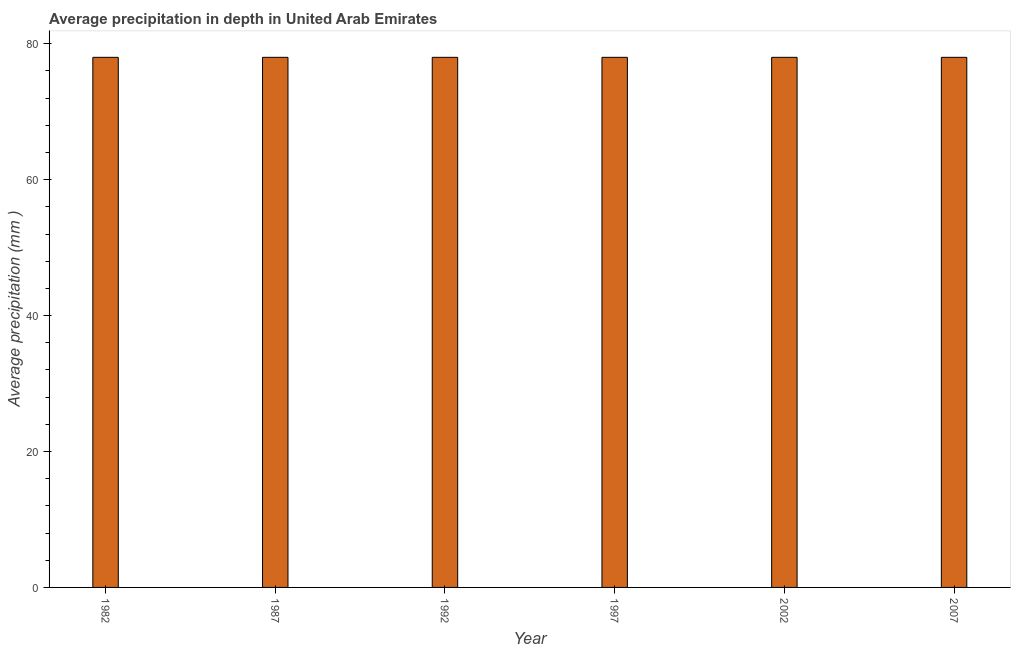Does the graph contain grids?
Provide a short and direct response. No. What is the title of the graph?
Keep it short and to the point. Average precipitation in depth in United Arab Emirates. What is the label or title of the X-axis?
Your answer should be very brief. Year. What is the label or title of the Y-axis?
Keep it short and to the point. Average precipitation (mm ). Across all years, what is the minimum average precipitation in depth?
Offer a terse response. 78. What is the sum of the average precipitation in depth?
Provide a succinct answer. 468. What is the difference between the average precipitation in depth in 1992 and 2002?
Your answer should be compact. 0. What is the average average precipitation in depth per year?
Your answer should be very brief. 78. What is the median average precipitation in depth?
Offer a terse response. 78. Do a majority of the years between 2002 and 1992 (inclusive) have average precipitation in depth greater than 40 mm?
Your response must be concise. Yes. Is the difference between the average precipitation in depth in 1982 and 2002 greater than the difference between any two years?
Keep it short and to the point. Yes. What is the difference between the highest and the second highest average precipitation in depth?
Keep it short and to the point. 0. What is the difference between the highest and the lowest average precipitation in depth?
Your answer should be very brief. 0. Are all the bars in the graph horizontal?
Ensure brevity in your answer.  No. What is the Average precipitation (mm ) in 1982?
Offer a terse response. 78. What is the Average precipitation (mm ) of 1992?
Give a very brief answer. 78. What is the Average precipitation (mm ) in 1997?
Your response must be concise. 78. What is the Average precipitation (mm ) in 2002?
Give a very brief answer. 78. What is the Average precipitation (mm ) of 2007?
Make the answer very short. 78. What is the difference between the Average precipitation (mm ) in 1982 and 1997?
Give a very brief answer. 0. What is the difference between the Average precipitation (mm ) in 1982 and 2002?
Your answer should be very brief. 0. What is the difference between the Average precipitation (mm ) in 1987 and 1997?
Provide a short and direct response. 0. What is the difference between the Average precipitation (mm ) in 1987 and 2002?
Keep it short and to the point. 0. What is the difference between the Average precipitation (mm ) in 1987 and 2007?
Your response must be concise. 0. What is the difference between the Average precipitation (mm ) in 1997 and 2002?
Offer a terse response. 0. What is the ratio of the Average precipitation (mm ) in 1982 to that in 2002?
Your response must be concise. 1. What is the ratio of the Average precipitation (mm ) in 1987 to that in 2002?
Your answer should be very brief. 1. What is the ratio of the Average precipitation (mm ) in 1992 to that in 2002?
Offer a terse response. 1. What is the ratio of the Average precipitation (mm ) in 1997 to that in 2007?
Keep it short and to the point. 1. What is the ratio of the Average precipitation (mm ) in 2002 to that in 2007?
Your response must be concise. 1. 